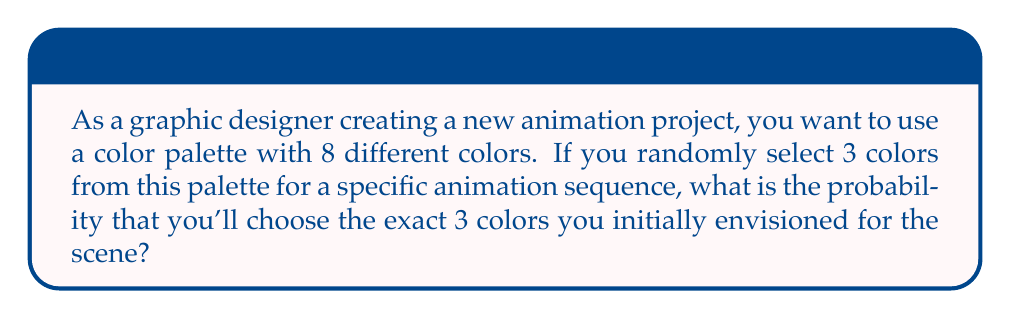What is the answer to this math problem? Let's approach this step-by-step:

1) First, we need to understand that this is a combination problem. The order of selection doesn't matter (it's not important which color is picked first, second, or third).

2) The total number of ways to choose 3 colors from 8 is given by the combination formula:

   $$\binom{8}{3} = \frac{8!}{3!(8-3)!} = \frac{8!}{3!5!}$$

3) Let's calculate this:
   $$\frac{8 * 7 * 6 * 5!}{(3 * 2 * 1) * 5!} = \frac{336}{6} = 56$$

4) There are 56 possible combinations of 3 colors from a palette of 8 colors.

5) Now, the probability of choosing the exact 3 colors you envisioned is just 1 out of these 56 possibilities.

6) Therefore, the probability is:

   $$P(\text{chosen 3 colors}) = \frac{1}{56}$$

This can be expressed as a decimal by dividing 1 by 56:

$$\frac{1}{56} \approx 0.0179$$

Or as a percentage:

$$\frac{1}{56} * 100\% \approx 1.79\%$$
Answer: $\frac{1}{56}$ or approximately 0.0179 or 1.79% 